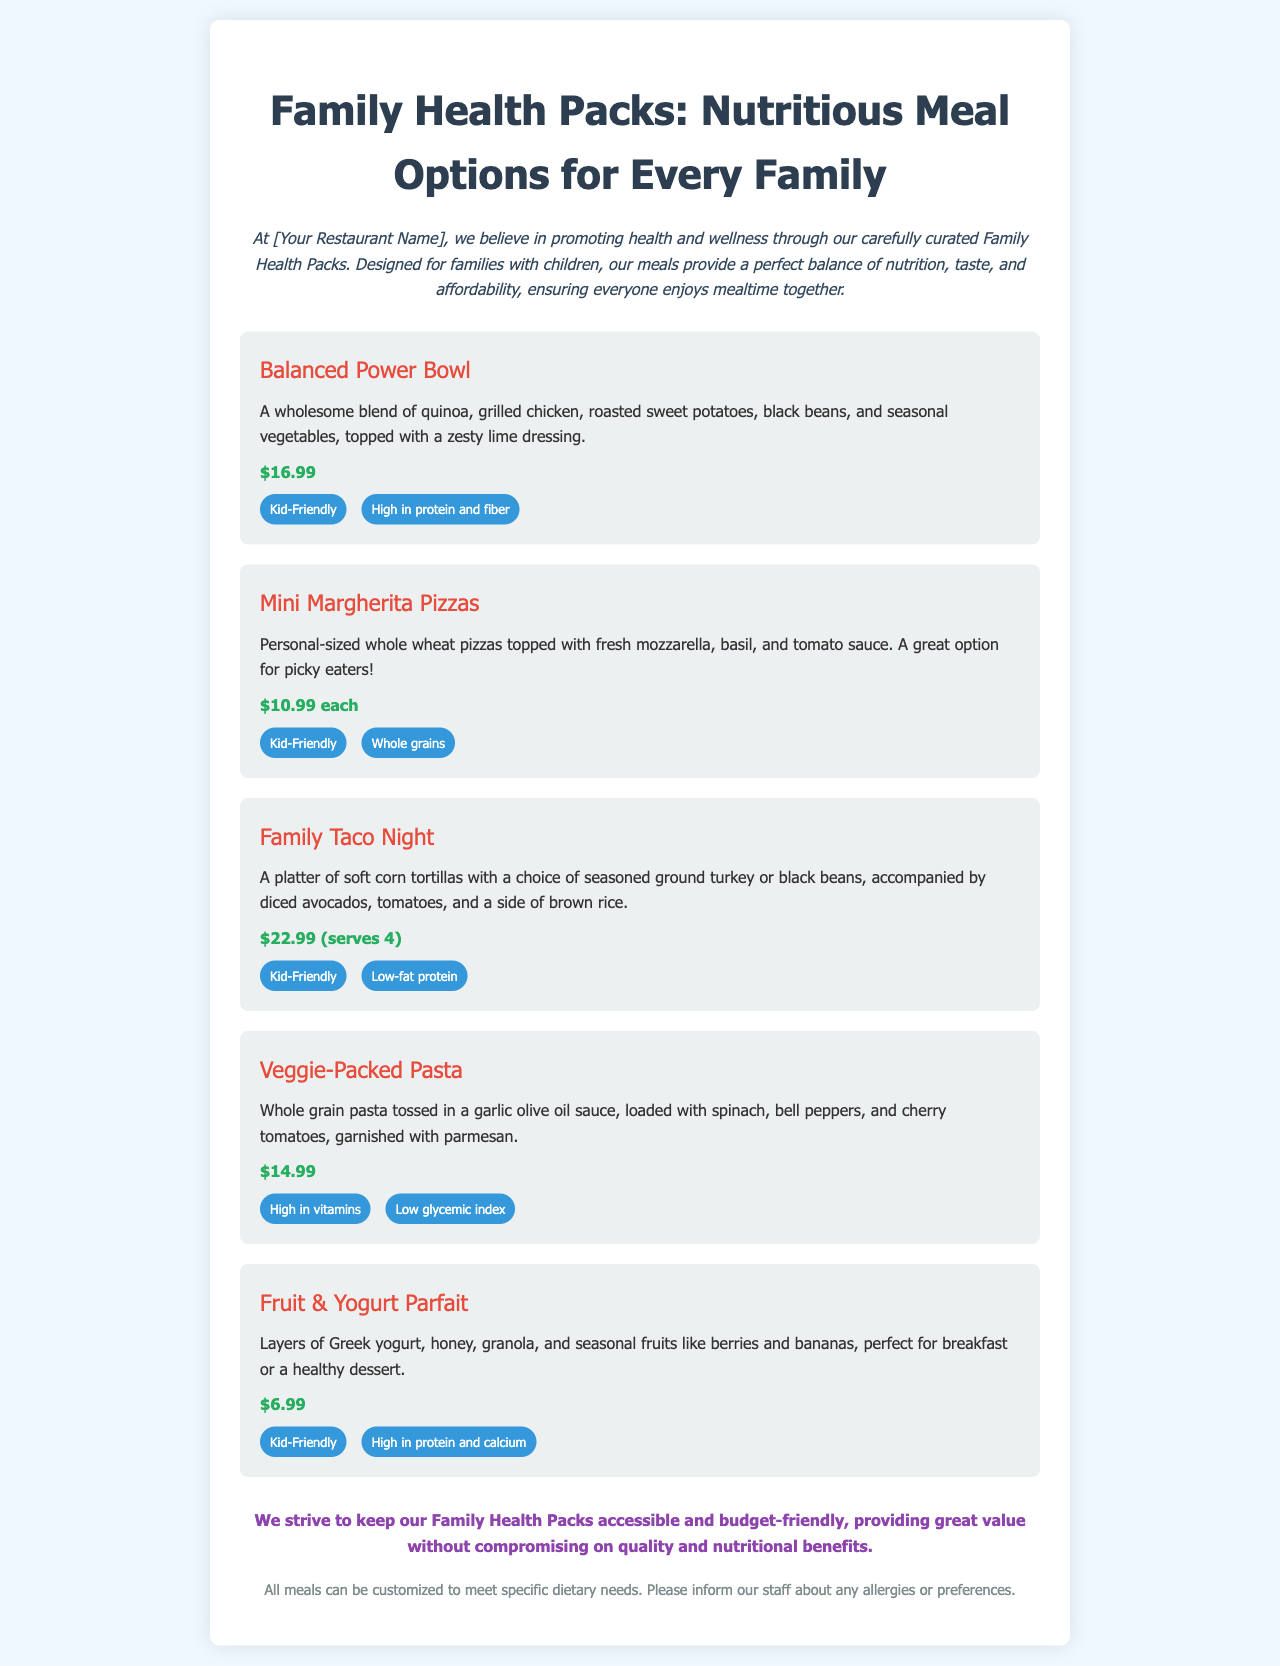What is the price of the Balanced Power Bowl? The price of the Balanced Power Bowl is listed directly in the document as $16.99.
Answer: $16.99 What type of crust is used for the Mini Margherita Pizzas? The Mini Margherita Pizzas are made with whole wheat crust, as mentioned in the description.
Answer: Whole wheat How many people does the Family Taco Night serve? The Family Taco Night is indicated to serve 4 people as stated in the price section.
Answer: 4 What are the main ingredients in the Veggie-Packed Pasta? The Veggie-Packed Pasta includes whole grain pasta, spinach, bell peppers, and cherry tomatoes, all of which are listed in the description.
Answer: Whole grain pasta, spinach, bell peppers, cherry tomatoes What is the main nutritional benefit of the Fruit & Yogurt Parfait? It is highlighted that the Fruit & Yogurt Parfait is high in protein and calcium according to the tags.
Answer: High in protein and calcium Which meal option has a zesty lime dressing? The Balanced Power Bowl is described as being topped with a zesty lime dressing.
Answer: Balanced Power Bowl What dietary needs can meals be customized for? The note mentions that all meals can be customized to meet specific dietary needs.
Answer: Specific dietary needs What color is the background of the menu? The background color of the menu is noted to be a soft light blue, referred to as #f0f8ff in the style section.
Answer: #f0f8ff 